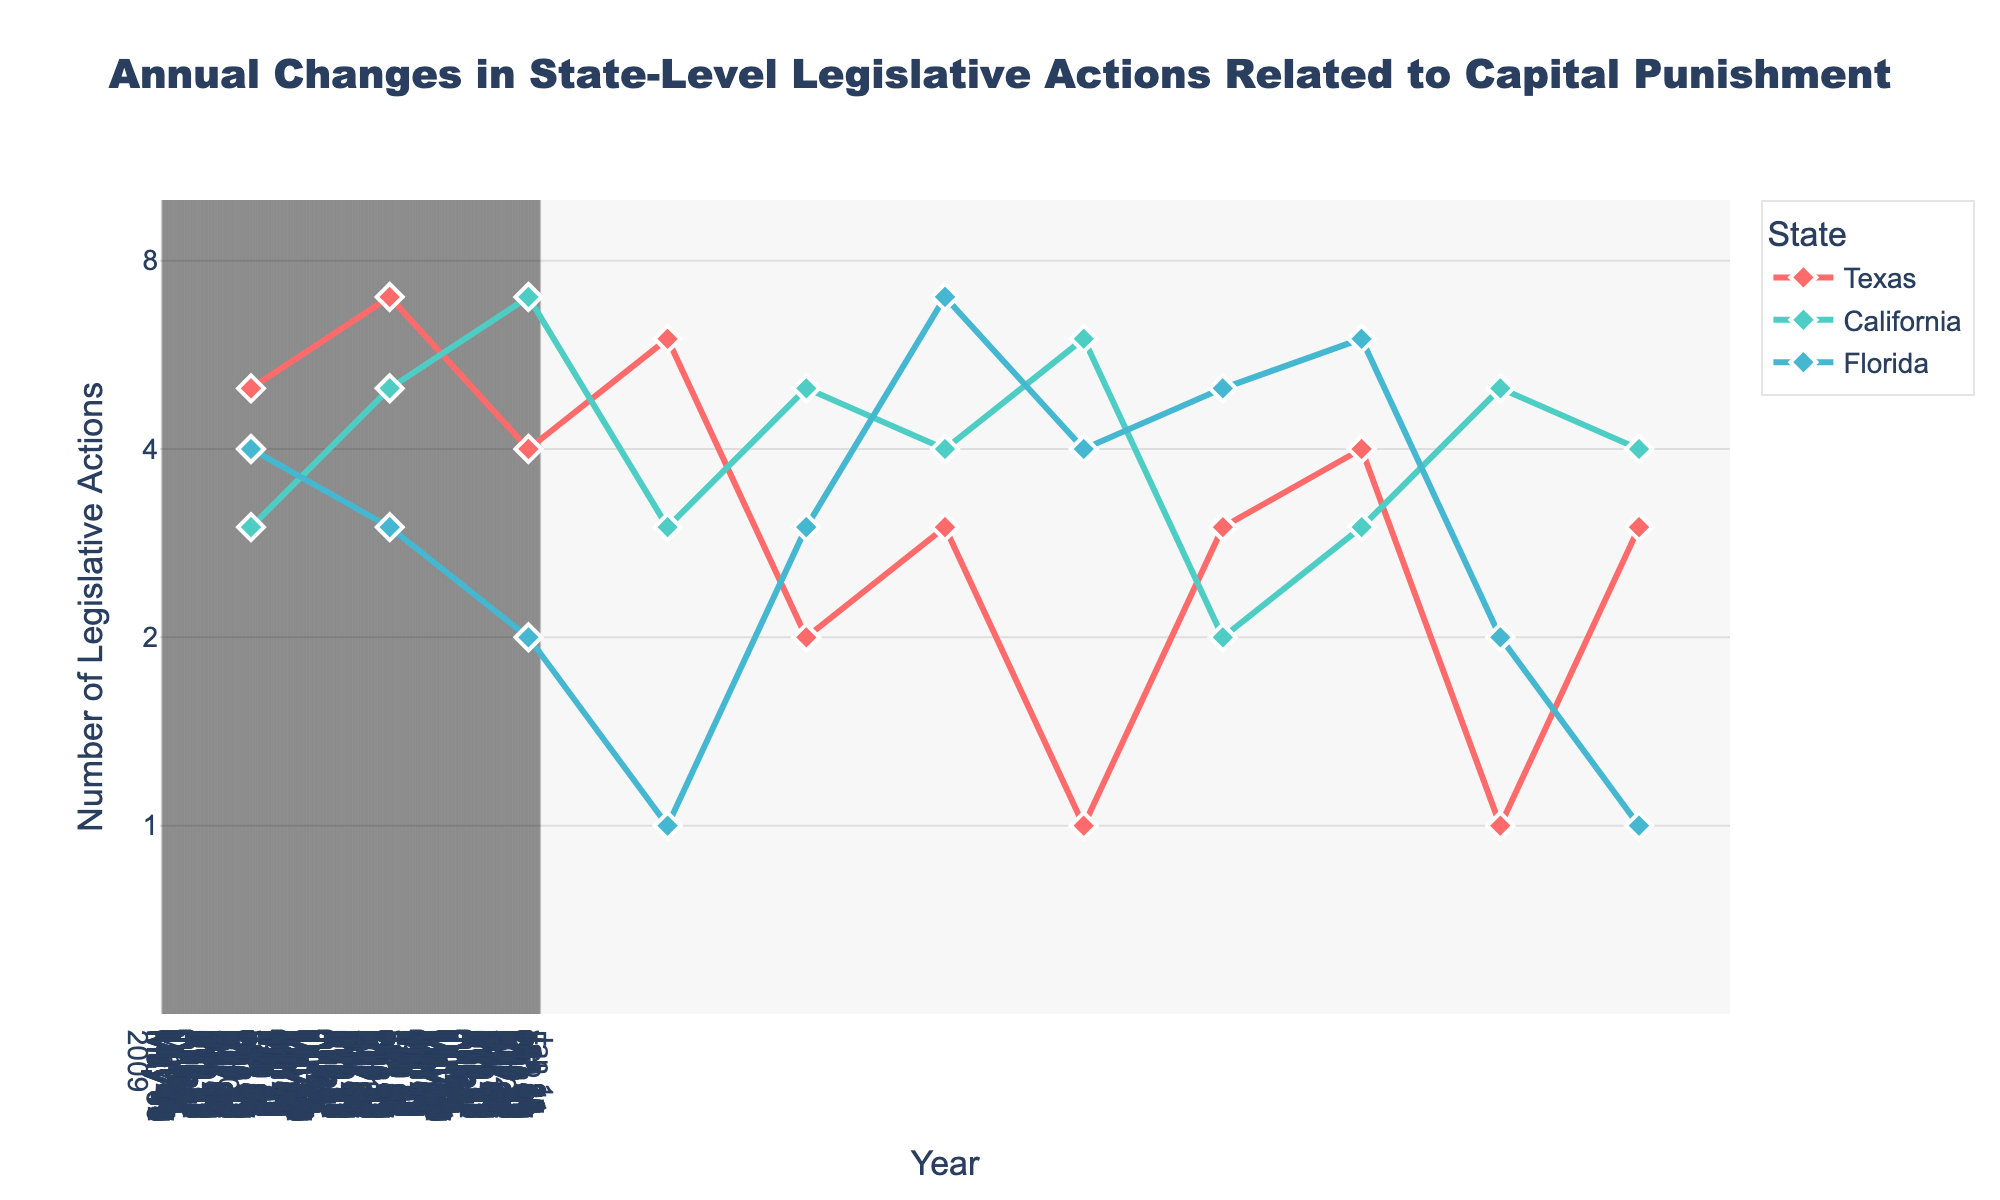What is the title of the figure? The title is displayed at the top center of the figure and reads "Annual Changes in State-Level Legislative Actions Related to Capital Punishment".
Answer: Annual Changes in State-Level Legislative Actions Related to Capital Punishment What states are represented in the figure? The legend at the right side of the figure lists all the states represented. The states are Texas, California, and Florida.
Answer: Texas, California, Florida What is the range of the y-axis? The y-axis is on a log scale with tick marks at 1, 2, 4, and 8, ranging from 0.5 to 10.
Answer: 0.5 to 10 Which state had the highest number of legislative actions in 2020? By looking at the plotted lines for 2020, California reaches the highest point on the y-axis.
Answer: California How do the number of legislative actions in Texas compare between 2016 and 2019? The plotted line for Texas shows points at 1 legislative action in 2016 and 1 legislative action in 2019, indicating no change.
Answer: No change What is the average number of legislative actions in Texas from 2010 to 2020? Adding the counts from the years 2010 (5), 2011 (7), 2012 (4), 2013 (6), 2014 (2), 2015 (3), 2016 (1), 2017 (3), 2018 (4), 2019 (1), and 2020 (3) gives a total of 39, and dividing by 11 gives an average of 3.55 (rounded).
Answer: 3.55 Which year saw the highest increase in legislative actions in Florida? Comparing the differences year by year for Florida, the highest increase is from 2015 (7) to 2016 (4), a decrease actually, so the highest is actually an increase from 2013 (1) to 2014 (3); otherwise, it's consistently downward.
Answer: 2013 to 2014 Between which years did California experience a decrease in legislative actions? California shows a decrease between 2011 (5) to 2010 (3), 2012 (7) to 2013 (3), 2014 (5) to 2017 (2), and 2018 (3) to 2019 (5).
Answer: 2011-2010; 2012-2013; 2014-2017; 2018-2019 How does the number of legislative actions in 2012 compare across the three states? Checking the value for 2012, Texas had 4, California had 7, and Florida had 2. California had the highest, followed by Texas, and then Florida.
Answer: California > Texas > Florida During which year did Texas have the lowest number of legislative actions? The plot shows the lowest point for Texas at y=1 in the years 2016 and 2019.
Answer: 2016 and 2019 